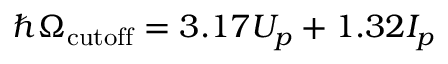Convert formula to latex. <formula><loc_0><loc_0><loc_500><loc_500>\hbar { \Omega } _ { c u t o f f } = 3 . 1 7 U _ { p } + 1 . 3 2 I _ { p }</formula> 